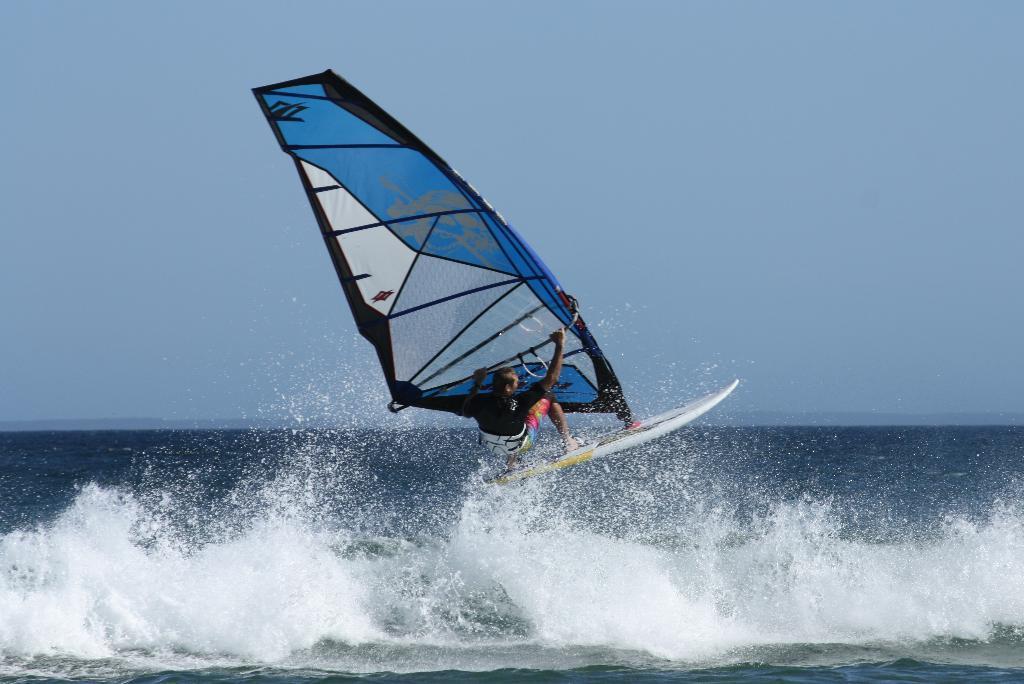Can you describe this image briefly? In the image there is a person windsurfing in the ocean and above its sky. 